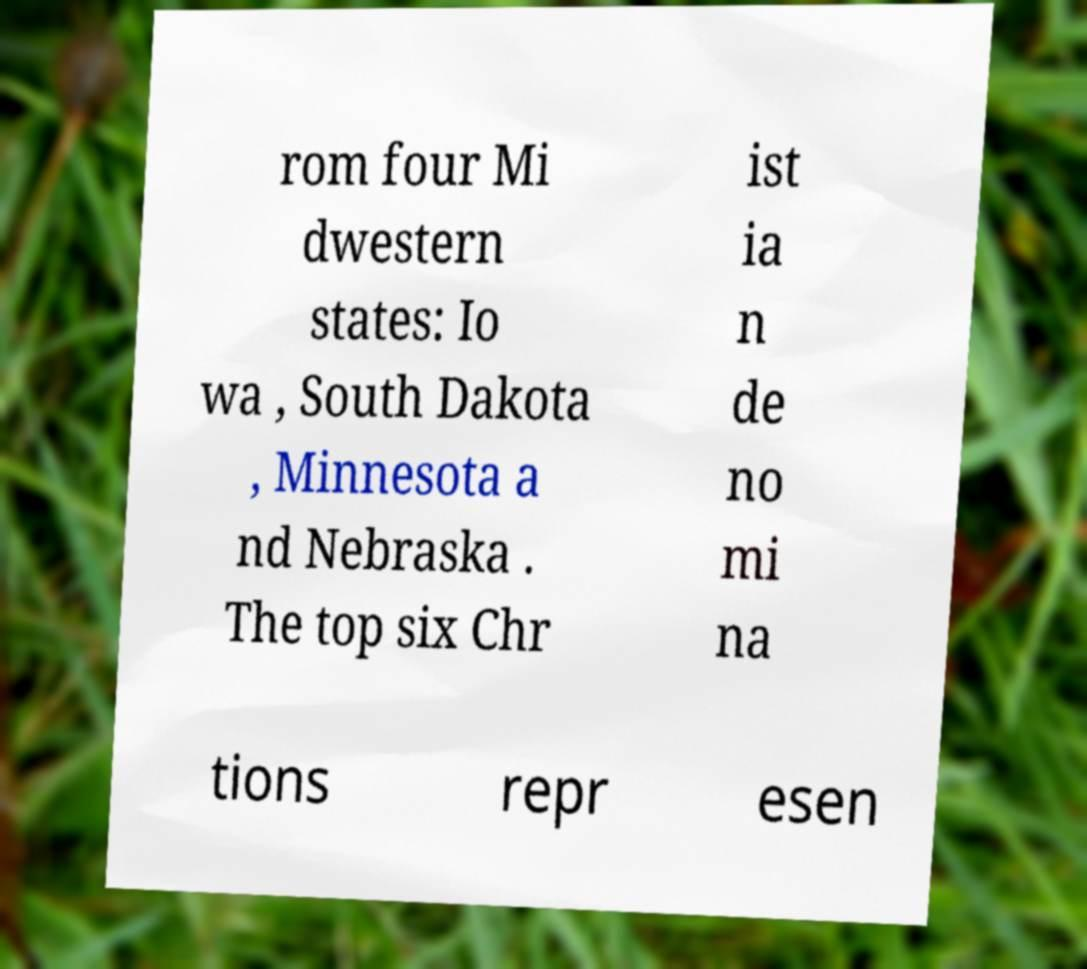Please identify and transcribe the text found in this image. rom four Mi dwestern states: Io wa , South Dakota , Minnesota a nd Nebraska . The top six Chr ist ia n de no mi na tions repr esen 